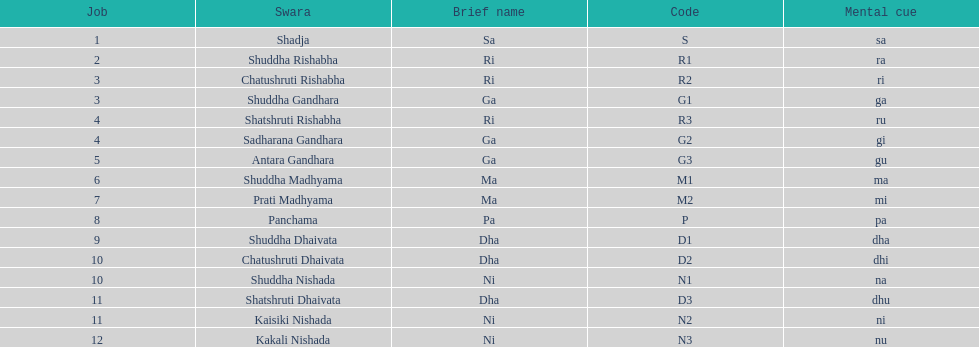How many swaras do not have dhaivata in their name? 13. 